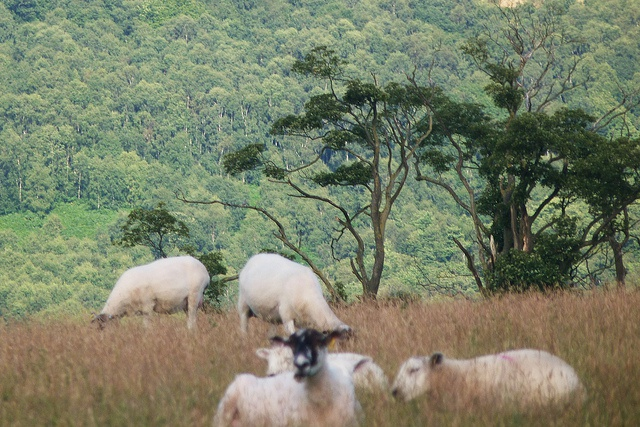Describe the objects in this image and their specific colors. I can see sheep in teal, darkgray, gray, and tan tones, sheep in teal, darkgray, lightgray, and gray tones, sheep in teal, lightgray, darkgray, and gray tones, sheep in teal, lightgray, darkgray, gray, and tan tones, and sheep in teal, darkgray, lightgray, and gray tones in this image. 